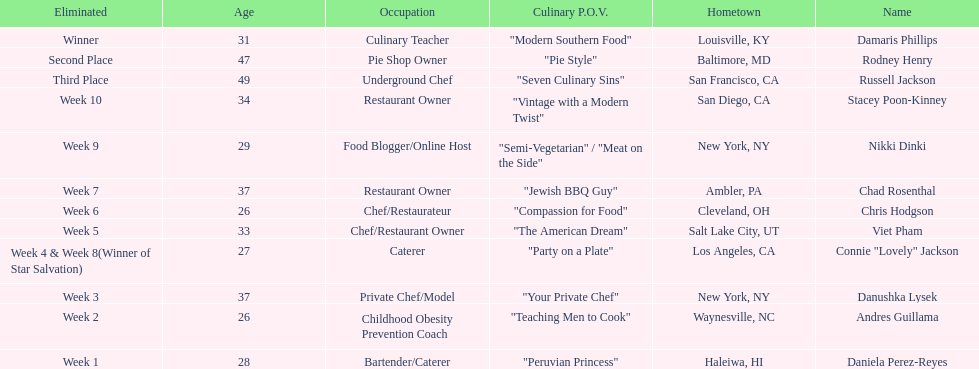Which competitor only lasted two weeks? Andres Guillama. 